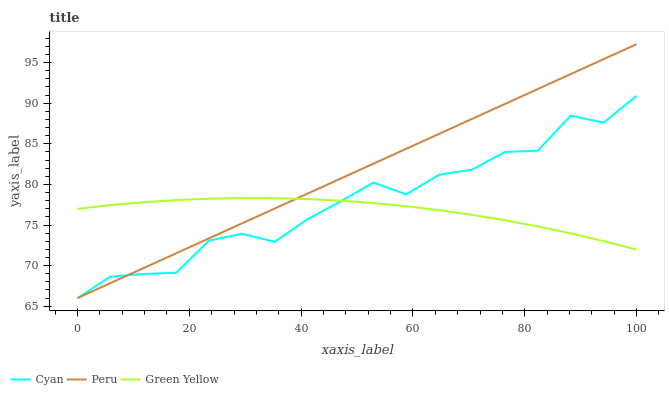Does Green Yellow have the minimum area under the curve?
Answer yes or no. Yes. Does Peru have the maximum area under the curve?
Answer yes or no. Yes. Does Peru have the minimum area under the curve?
Answer yes or no. No. Does Green Yellow have the maximum area under the curve?
Answer yes or no. No. Is Peru the smoothest?
Answer yes or no. Yes. Is Cyan the roughest?
Answer yes or no. Yes. Is Green Yellow the smoothest?
Answer yes or no. No. Is Green Yellow the roughest?
Answer yes or no. No. Does Cyan have the lowest value?
Answer yes or no. Yes. Does Green Yellow have the lowest value?
Answer yes or no. No. Does Peru have the highest value?
Answer yes or no. Yes. Does Green Yellow have the highest value?
Answer yes or no. No. Does Green Yellow intersect Peru?
Answer yes or no. Yes. Is Green Yellow less than Peru?
Answer yes or no. No. Is Green Yellow greater than Peru?
Answer yes or no. No. 